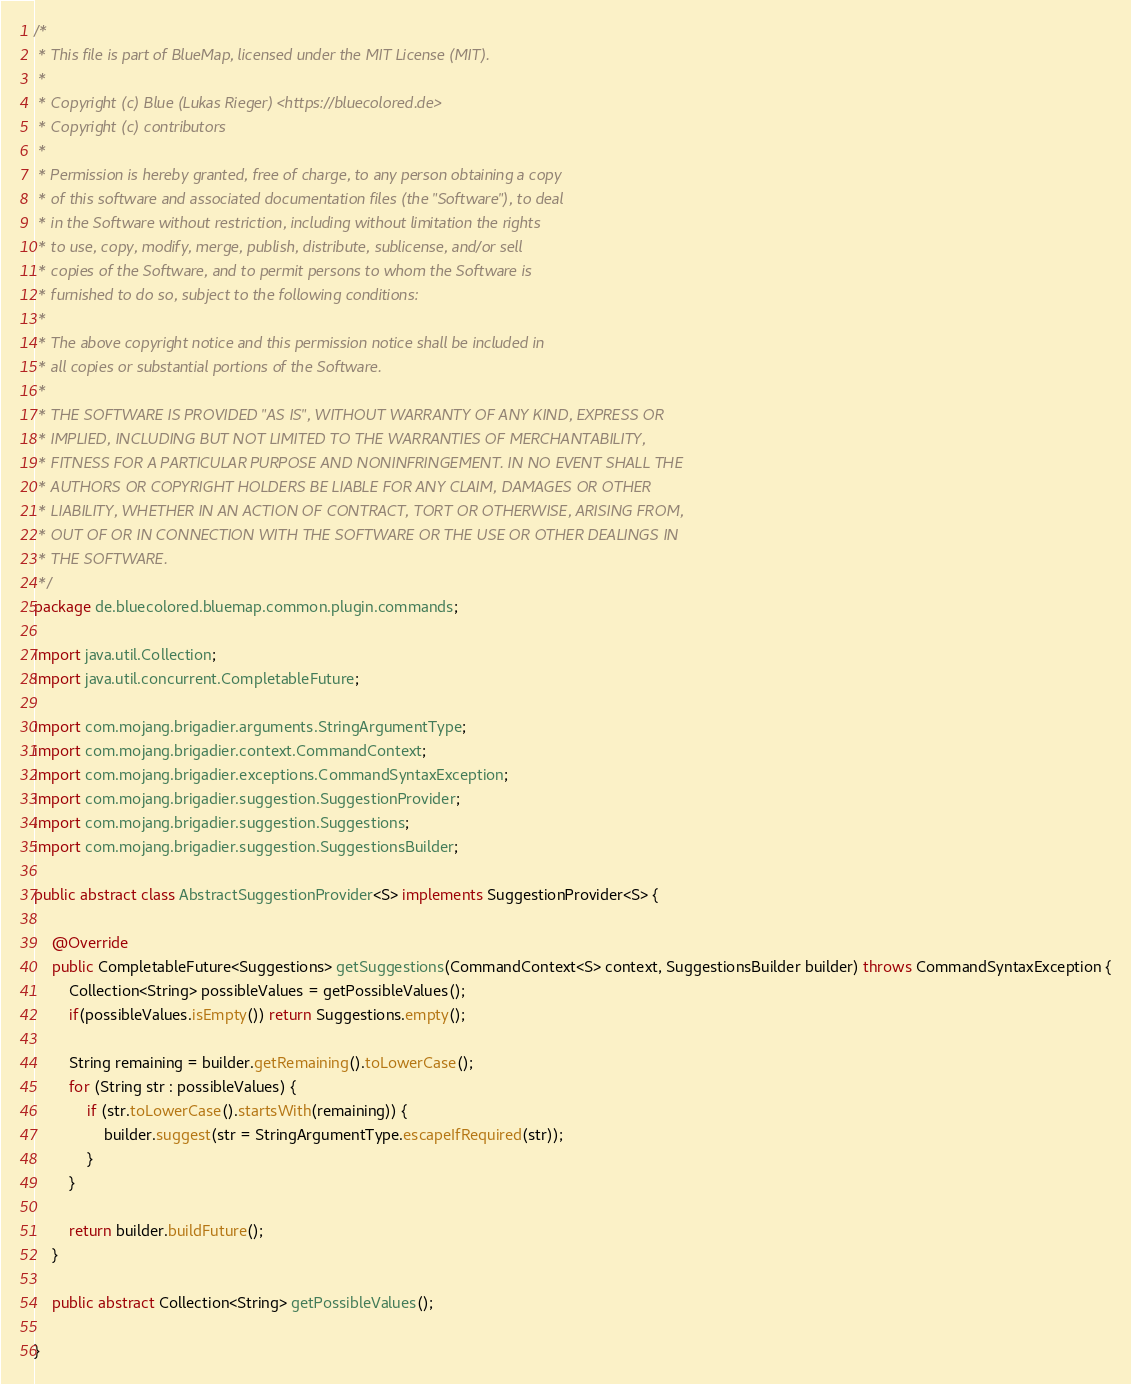<code> <loc_0><loc_0><loc_500><loc_500><_Java_>/*
 * This file is part of BlueMap, licensed under the MIT License (MIT).
 *
 * Copyright (c) Blue (Lukas Rieger) <https://bluecolored.de>
 * Copyright (c) contributors
 *
 * Permission is hereby granted, free of charge, to any person obtaining a copy
 * of this software and associated documentation files (the "Software"), to deal
 * in the Software without restriction, including without limitation the rights
 * to use, copy, modify, merge, publish, distribute, sublicense, and/or sell
 * copies of the Software, and to permit persons to whom the Software is
 * furnished to do so, subject to the following conditions:
 *
 * The above copyright notice and this permission notice shall be included in
 * all copies or substantial portions of the Software.
 *
 * THE SOFTWARE IS PROVIDED "AS IS", WITHOUT WARRANTY OF ANY KIND, EXPRESS OR
 * IMPLIED, INCLUDING BUT NOT LIMITED TO THE WARRANTIES OF MERCHANTABILITY,
 * FITNESS FOR A PARTICULAR PURPOSE AND NONINFRINGEMENT. IN NO EVENT SHALL THE
 * AUTHORS OR COPYRIGHT HOLDERS BE LIABLE FOR ANY CLAIM, DAMAGES OR OTHER
 * LIABILITY, WHETHER IN AN ACTION OF CONTRACT, TORT OR OTHERWISE, ARISING FROM,
 * OUT OF OR IN CONNECTION WITH THE SOFTWARE OR THE USE OR OTHER DEALINGS IN
 * THE SOFTWARE.
 */
package de.bluecolored.bluemap.common.plugin.commands;

import java.util.Collection;
import java.util.concurrent.CompletableFuture;

import com.mojang.brigadier.arguments.StringArgumentType;
import com.mojang.brigadier.context.CommandContext;
import com.mojang.brigadier.exceptions.CommandSyntaxException;
import com.mojang.brigadier.suggestion.SuggestionProvider;
import com.mojang.brigadier.suggestion.Suggestions;
import com.mojang.brigadier.suggestion.SuggestionsBuilder;

public abstract class AbstractSuggestionProvider<S> implements SuggestionProvider<S> {
	
	@Override
	public CompletableFuture<Suggestions> getSuggestions(CommandContext<S> context, SuggestionsBuilder builder) throws CommandSyntaxException {
		Collection<String> possibleValues = getPossibleValues();
		if(possibleValues.isEmpty()) return Suggestions.empty();

		String remaining = builder.getRemaining().toLowerCase();
		for (String str : possibleValues) {
			if (str.toLowerCase().startsWith(remaining)) {
				builder.suggest(str = StringArgumentType.escapeIfRequired(str));
			}
		}
		
		return builder.buildFuture();
	}

	public abstract Collection<String> getPossibleValues();
	
}
</code> 